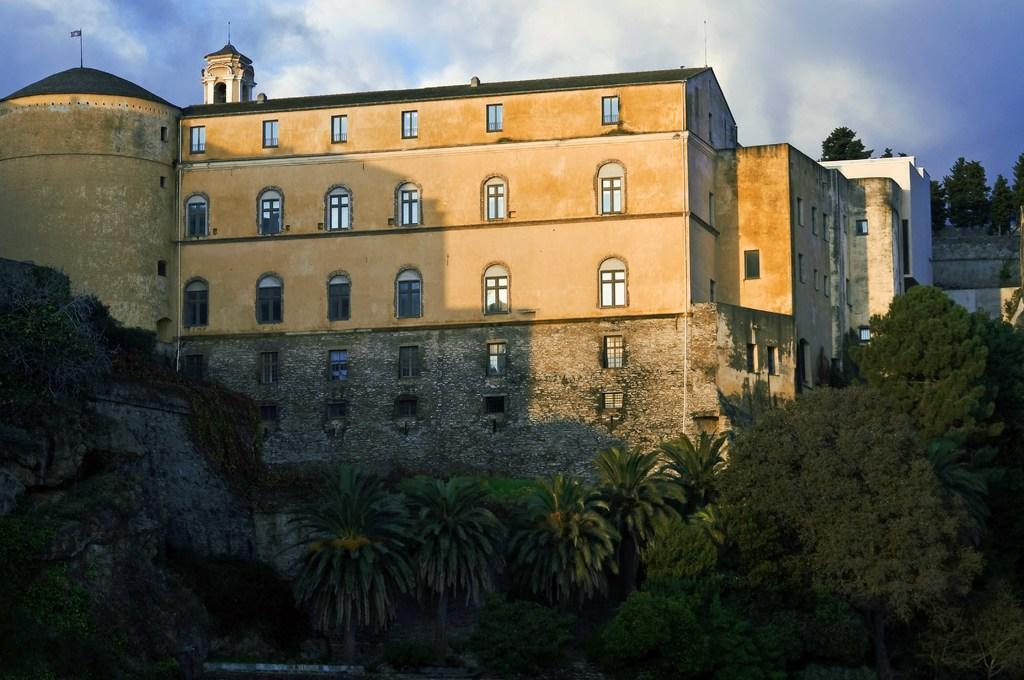What type of vegetation is at the bottom of the image? There are trees at the bottom of the image. What can be seen in the background of the image? There are buildings, windows, and poles visible in the background. Where is the flag located in the image? The flag is on the left side of the image. What is visible in the sky in the image? Clouds are present in the sky. Can you tell me how many doors are visible in the image? There are no doors present in the image. Is your uncle riding a bike in the image? There is no person, including your uncle, or bike present in the image. 